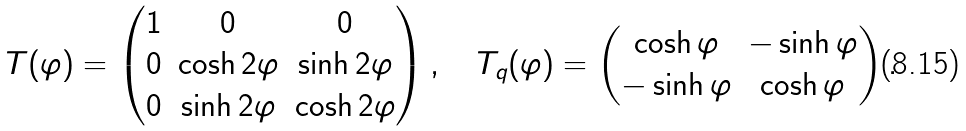Convert formula to latex. <formula><loc_0><loc_0><loc_500><loc_500>T ( \varphi ) = \begin{pmatrix} 1 & 0 & 0 \\ 0 & \cosh 2 \varphi & \sinh 2 \varphi \\ 0 & \sinh 2 \varphi & \cosh 2 \varphi \\ \end{pmatrix} , \quad T _ { q } ( \varphi ) = \begin{pmatrix} \cosh \varphi & - \sinh \varphi \\ - \sinh \varphi & \cosh \varphi \\ \end{pmatrix} .</formula> 